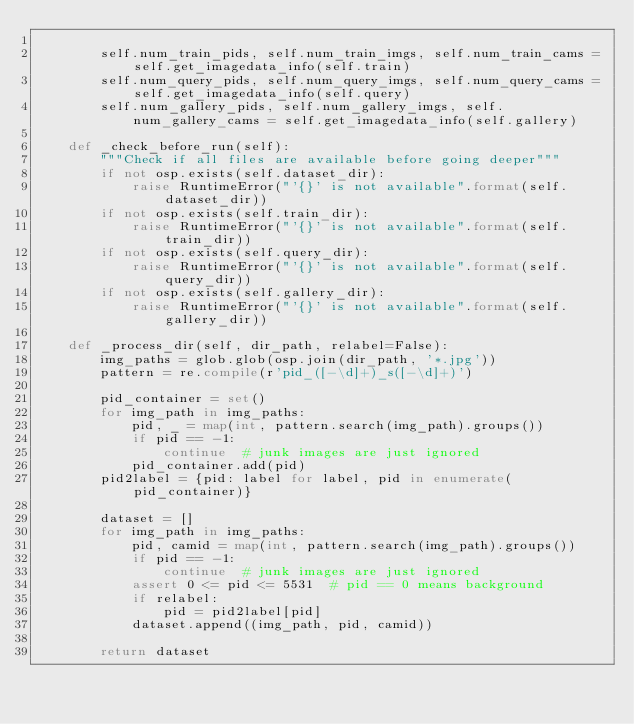<code> <loc_0><loc_0><loc_500><loc_500><_Python_>
        self.num_train_pids, self.num_train_imgs, self.num_train_cams = self.get_imagedata_info(self.train)
        self.num_query_pids, self.num_query_imgs, self.num_query_cams = self.get_imagedata_info(self.query)
        self.num_gallery_pids, self.num_gallery_imgs, self.num_gallery_cams = self.get_imagedata_info(self.gallery)

    def _check_before_run(self):
        """Check if all files are available before going deeper"""
        if not osp.exists(self.dataset_dir):
            raise RuntimeError("'{}' is not available".format(self.dataset_dir))
        if not osp.exists(self.train_dir):
            raise RuntimeError("'{}' is not available".format(self.train_dir))
        if not osp.exists(self.query_dir):
            raise RuntimeError("'{}' is not available".format(self.query_dir))
        if not osp.exists(self.gallery_dir):
            raise RuntimeError("'{}' is not available".format(self.gallery_dir))

    def _process_dir(self, dir_path, relabel=False):
        img_paths = glob.glob(osp.join(dir_path, '*.jpg'))
        pattern = re.compile(r'pid_([-\d]+)_s([-\d]+)')

        pid_container = set()
        for img_path in img_paths:
            pid, _ = map(int, pattern.search(img_path).groups())
            if pid == -1:
                continue  # junk images are just ignored
            pid_container.add(pid)
        pid2label = {pid: label for label, pid in enumerate(pid_container)}

        dataset = []
        for img_path in img_paths:
            pid, camid = map(int, pattern.search(img_path).groups())
            if pid == -1:
                continue  # junk images are just ignored
            assert 0 <= pid <= 5531  # pid == 0 means background
            if relabel:
                pid = pid2label[pid]
            dataset.append((img_path, pid, camid))

        return dataset
</code> 